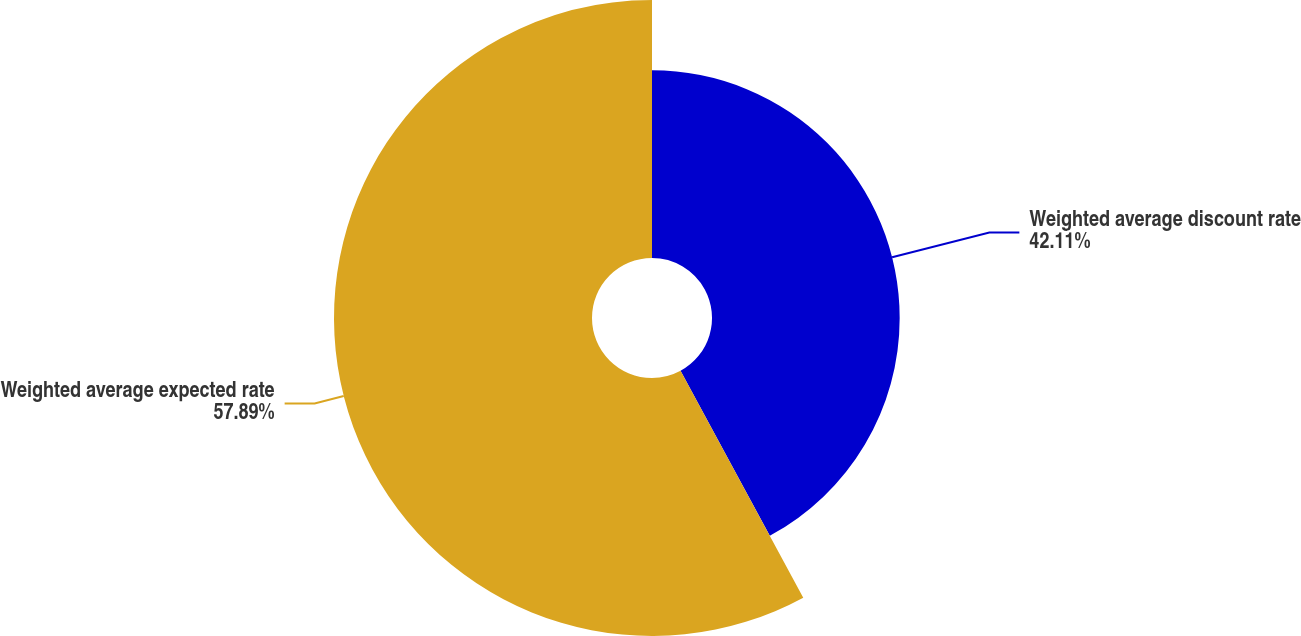<chart> <loc_0><loc_0><loc_500><loc_500><pie_chart><fcel>Weighted average discount rate<fcel>Weighted average expected rate<nl><fcel>42.11%<fcel>57.89%<nl></chart> 